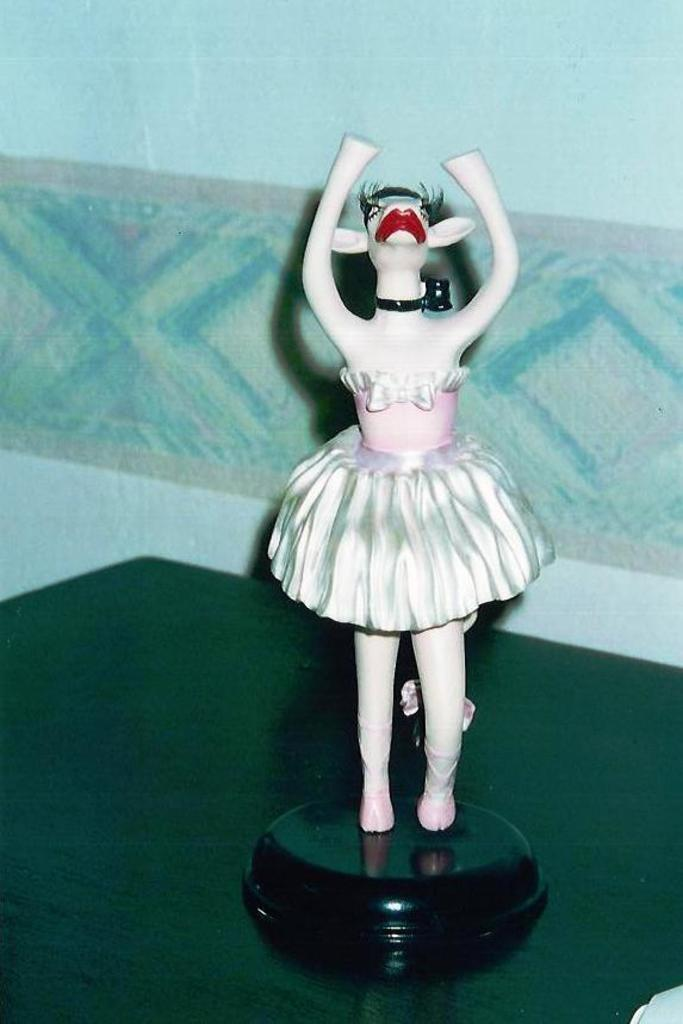What object can be seen in the image? There is a toy in the image. What is the color of the surface the toy is on? The toy is on a green surface. What can be seen in the background of the image? There is a wall in the background of the image. How many ducks are visible in the image? There are no ducks present in the image. What type of donkey can be seen interacting with the toy in the image? There is no donkey present in the image, and the toy is not interacting with any animal. 